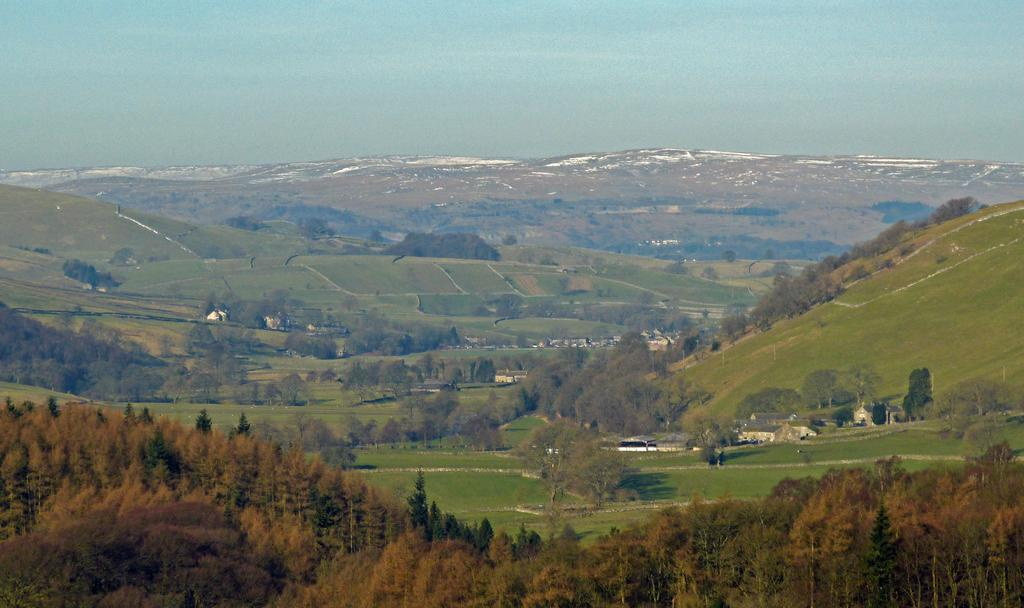What type of vegetation can be seen in the image? There are trees in the image. What colors are the trees in the image? The trees have brown and green colors. What is visible beneath the trees in the image? The ground is visible in the image. What type of structures can be seen in the image? There are buildings in the image. What natural feature is visible in the distance in the image? There are mountains in the image. What is visible in the background of the image? The sky is visible in the background of the image. Where is the grandmother sitting with her sheet in the image? There is no grandmother or sheet present in the image. 